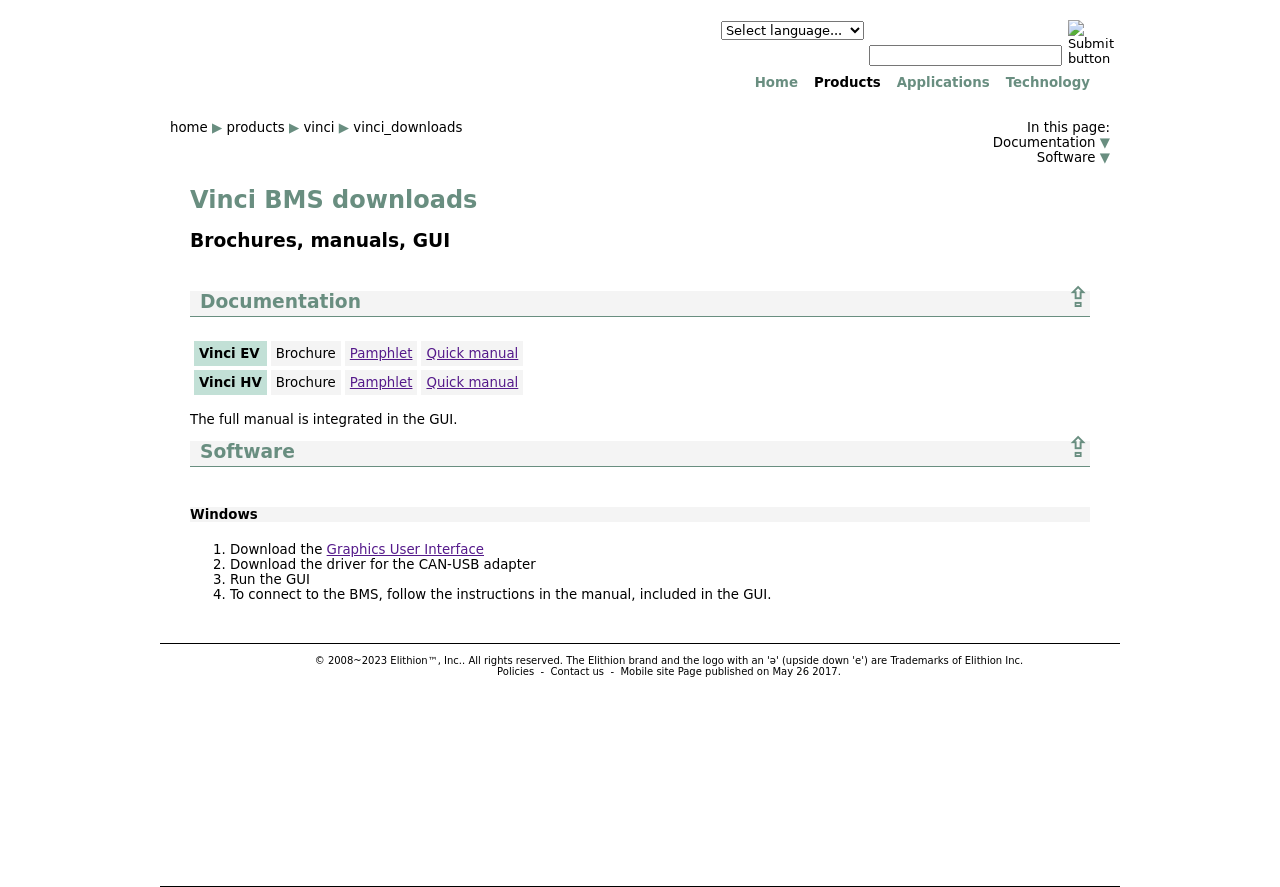Could you detail the process for assembling this website using HTML? Assembling a website with HTML involves several key steps: Firstly, you would define the structure using HTML tags like <html>, <head>, and <body>. Inside the <head> section, you can link to CSS for styling and JavaScript files for interactivity. The <body> section then contains the content of your pages, structured with headers (<h1>-<h6>), paragraphs (<p>), lists (<ul>, <ol>), and other HTML elements. Images and multimedia can be embedded with <img> and <video> tags. Finally, you ensure that the website is accessible and semantic by using appropriate tags and attributes. 